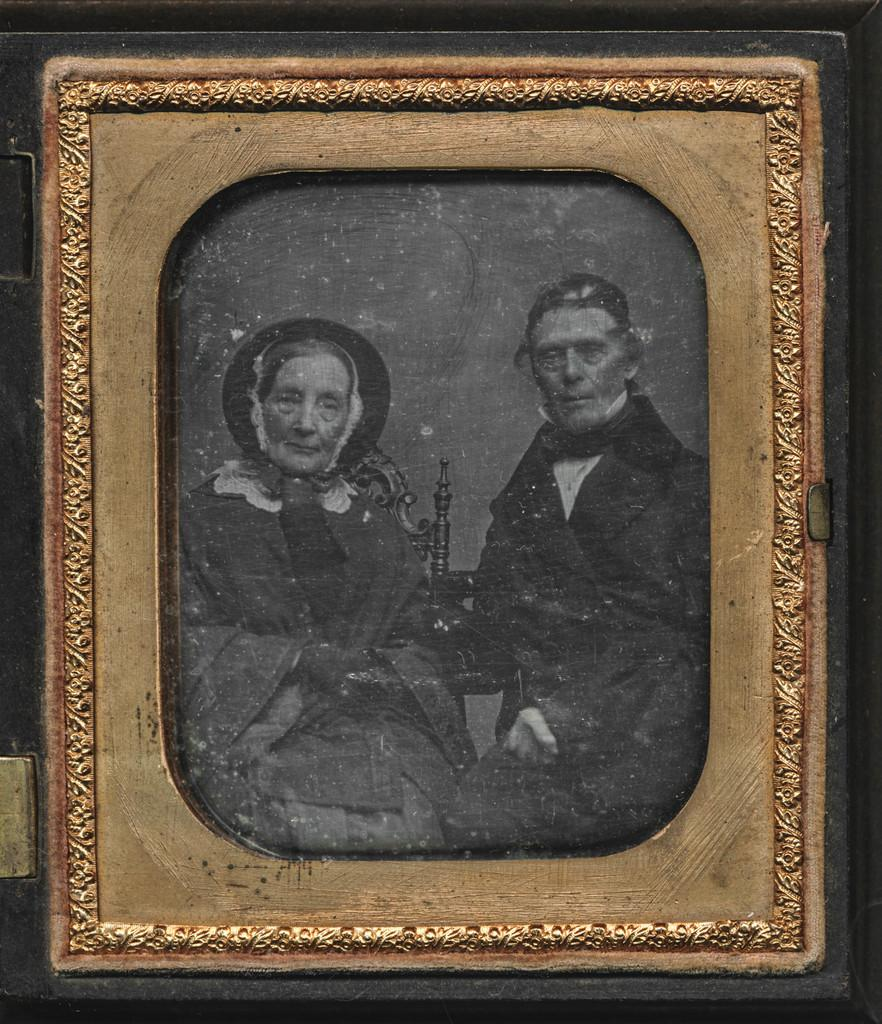What object is present in the photo frame in the image? The photo in the frame contains an object. Can you describe the people in the photo? The photo in the frame contains two people. What activity is the beggar performing in the image? There is no beggar present in the image. Where did the people in the photo go on their trip? There is no trip mentioned in the image; it only contains a photo frame with a photo of two people and an object. 